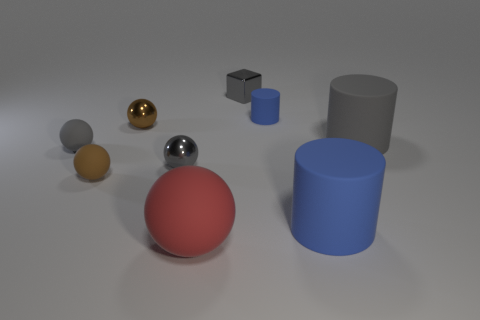Subtract all red spheres. How many spheres are left? 4 Subtract all brown rubber balls. How many balls are left? 4 Add 1 blue matte objects. How many objects exist? 10 Subtract all blue spheres. Subtract all blue cylinders. How many spheres are left? 5 Subtract all blocks. How many objects are left? 8 Add 8 big gray matte things. How many big gray matte things exist? 9 Subtract 0 green blocks. How many objects are left? 9 Subtract all red spheres. Subtract all small cyan rubber blocks. How many objects are left? 8 Add 7 large red rubber objects. How many large red rubber objects are left? 8 